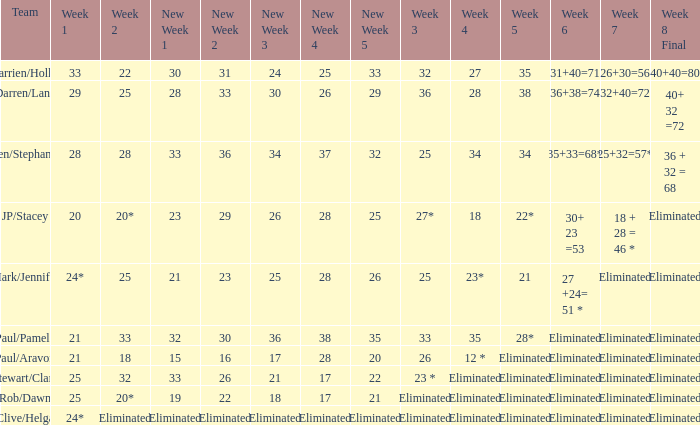Name the week 3 of 36 29.0. Would you be able to parse every entry in this table? {'header': ['Team', 'Week 1', 'Week 2', 'New Week 1', 'New Week 2', 'New Week 3', 'New Week 4', 'New Week 5', 'Week 3', 'Week 4', 'Week 5', 'Week 6', 'Week 7', 'Week 8 Final'], 'rows': [['Darrien/Hollie', '33', '22', '30', '31', '24', '25', '33', '32', '27', '35', '31+40=71', '26+30=56', '40+40=80'], ['Darren/Lana', '29', '25', '28', '33', '30', '26', '29', '36', '28', '38', '36+38=74', '32+40=72', '40+ 32 =72'], ['Ben/Stephanie', '28', '28', '33', '36', '34', '37', '32', '25', '34', '34', '35+33=68*', '25+32=57*', '36 + 32 = 68'], ['JP/Stacey', '20', '20*', '23', '29', '26', '28', '25', '27*', '18', '22*', '30+ 23 =53', '18 + 28 = 46 *', 'Eliminated'], ['Mark/Jennifer', '24*', '25', '21', '23', '25', '28', '26', '25', '23*', '21', '27 +24= 51 *', 'Eliminated', 'Eliminated'], ['Paul/Pamela', '21', '33', '32', '30', '36', '38', '35', '33', '35', '28*', 'Eliminated', 'Eliminated', 'Eliminated'], ['Paul/Aravon', '21', '18', '15', '16', '17', '28', '20', '26', '12 *', 'Eliminated', 'Eliminated', 'Eliminated', 'Eliminated'], ['Stewart/Clare', '25', '32', '33', '26', '21', '17', '22', '23 *', 'Eliminated', 'Eliminated', 'Eliminated', 'Eliminated', 'Eliminated'], ['Rob/Dawn', '25', '20*', '19', '22', '18', '17', '21', 'Eliminated', 'Eliminated', 'Eliminated', 'Eliminated', 'Eliminated', 'Eliminated'], ['Clive/Helga', '24*', 'Eliminated', 'Eliminated', 'Eliminated', 'Eliminated', 'Eliminated', 'Eliminated', 'Eliminated', 'Eliminated', 'Eliminated', 'Eliminated', 'Eliminated', 'Eliminated']]} 